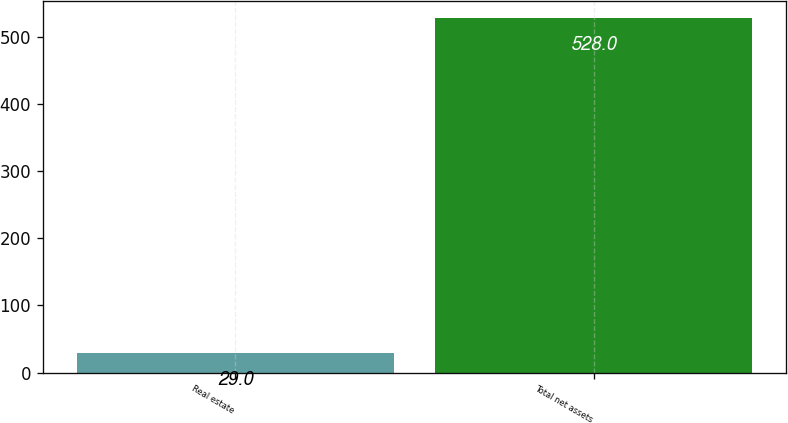Convert chart to OTSL. <chart><loc_0><loc_0><loc_500><loc_500><bar_chart><fcel>Real estate<fcel>Total net assets<nl><fcel>29<fcel>528<nl></chart> 